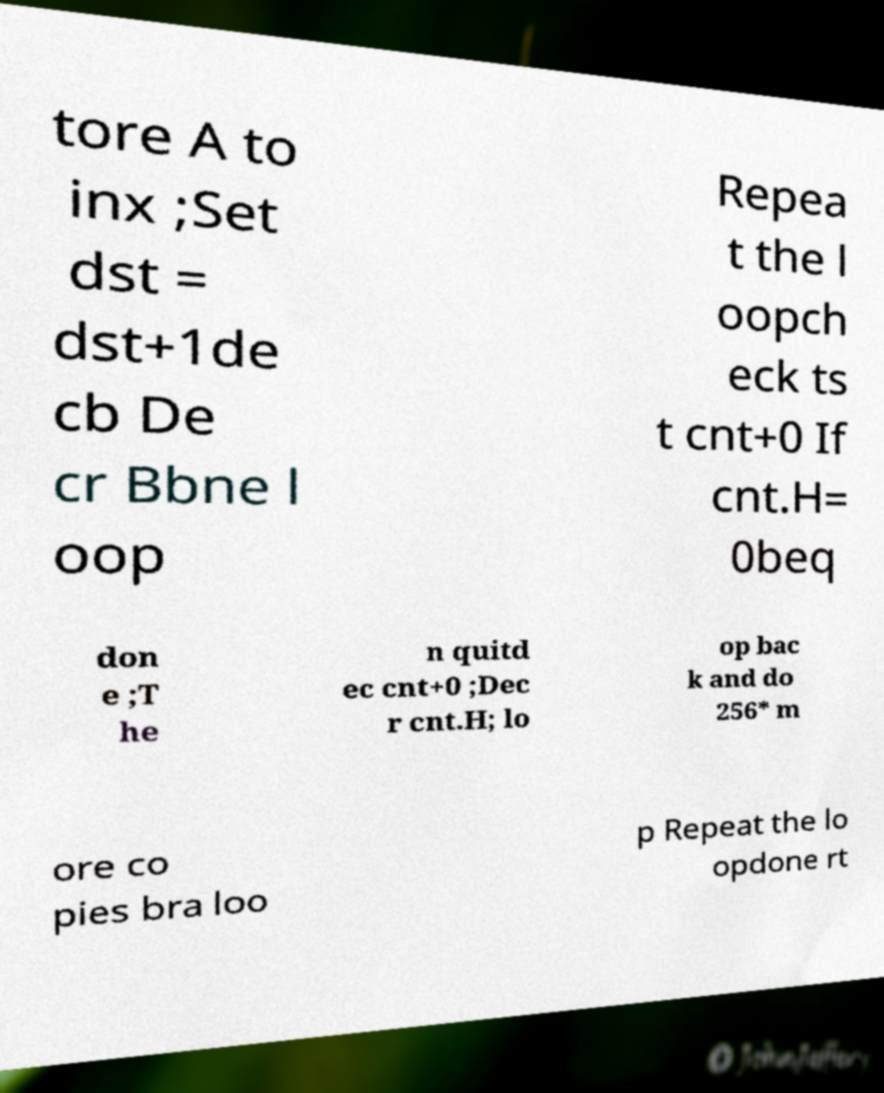For documentation purposes, I need the text within this image transcribed. Could you provide that? tore A to inx ;Set dst = dst+1de cb De cr Bbne l oop Repea t the l oopch eck ts t cnt+0 If cnt.H= 0beq don e ;T he n quitd ec cnt+0 ;Dec r cnt.H; lo op bac k and do 256* m ore co pies bra loo p Repeat the lo opdone rt 